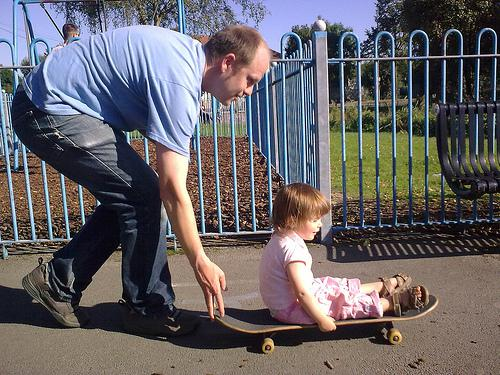Question: where is this taken place?
Choices:
A. Park.
B. Playground.
C. School gym.
D. At a park.
Answer with the letter. Answer: D Question: what color are the wheels?
Choices:
A. Silver.
B. Black.
C. Yellow.
D. White.
Answer with the letter. Answer: C Question: what color is the man's shirt?
Choices:
A. Gray.
B. Blue.
C. Black.
D. Red.
Answer with the letter. Answer: B 